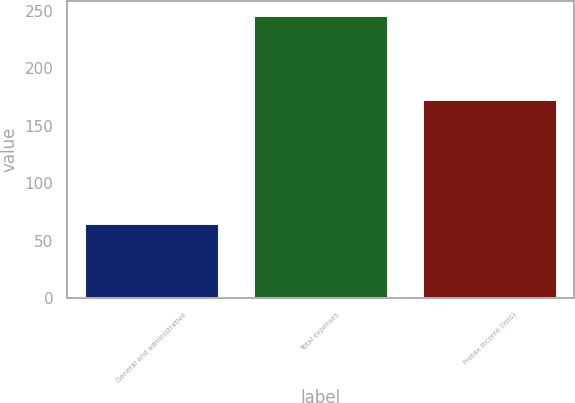<chart> <loc_0><loc_0><loc_500><loc_500><bar_chart><fcel>General and administrative<fcel>Total expenses<fcel>Pretax income (loss)<nl><fcel>65<fcel>246<fcel>173<nl></chart> 